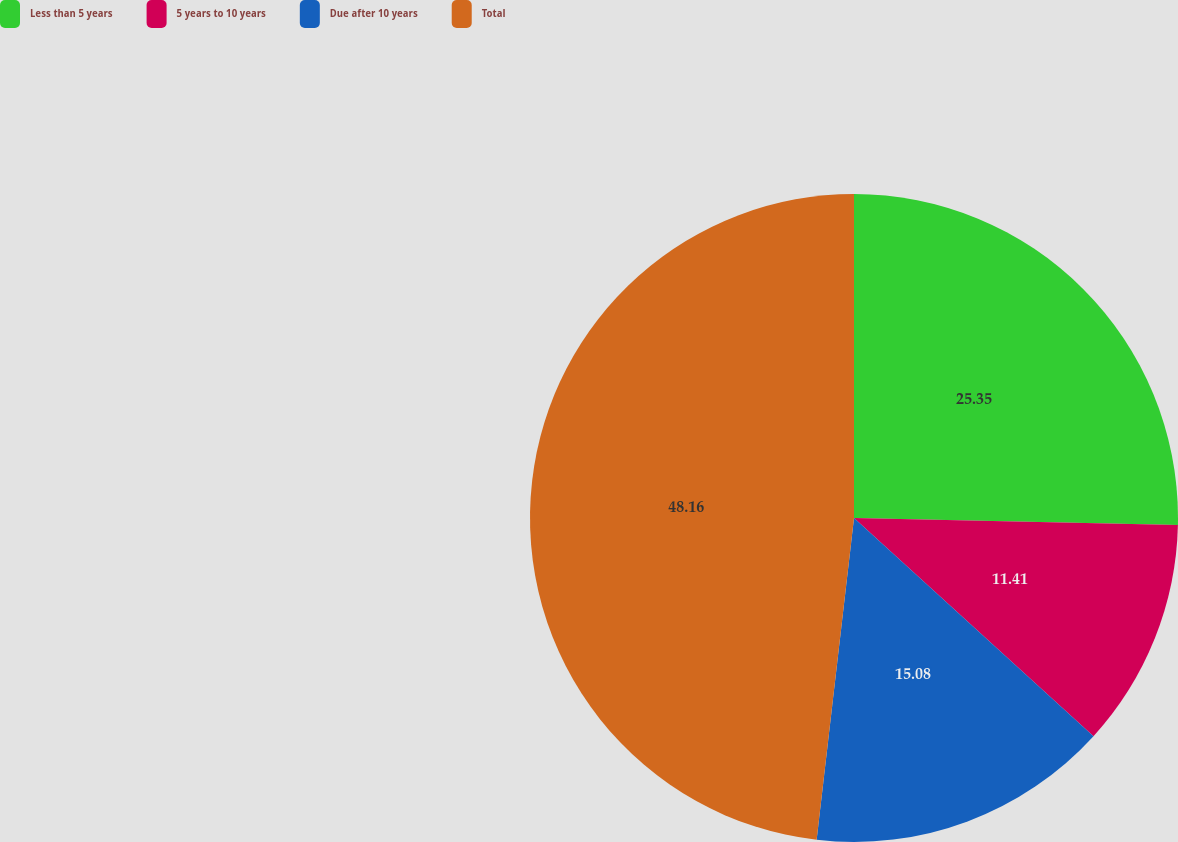Convert chart. <chart><loc_0><loc_0><loc_500><loc_500><pie_chart><fcel>Less than 5 years<fcel>5 years to 10 years<fcel>Due after 10 years<fcel>Total<nl><fcel>25.35%<fcel>11.41%<fcel>15.08%<fcel>48.16%<nl></chart> 